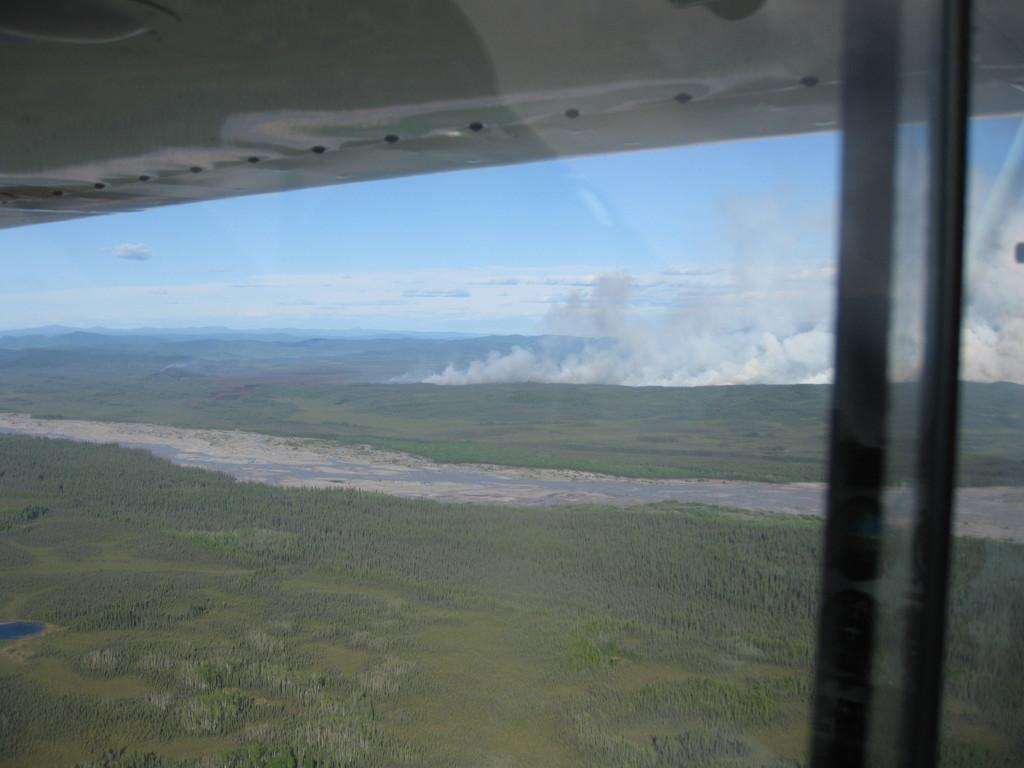What type of vegetation can be seen in the image? There are trees in the image. What natural element is visible in the image besides the trees? There is water visible in the image. What can be seen in the sky in the image? There are clouds in the sky in the image. How does the daughter feel about the clouds in the image? There is no daughter present in the image, so it is not possible to determine her feelings about the clouds. 